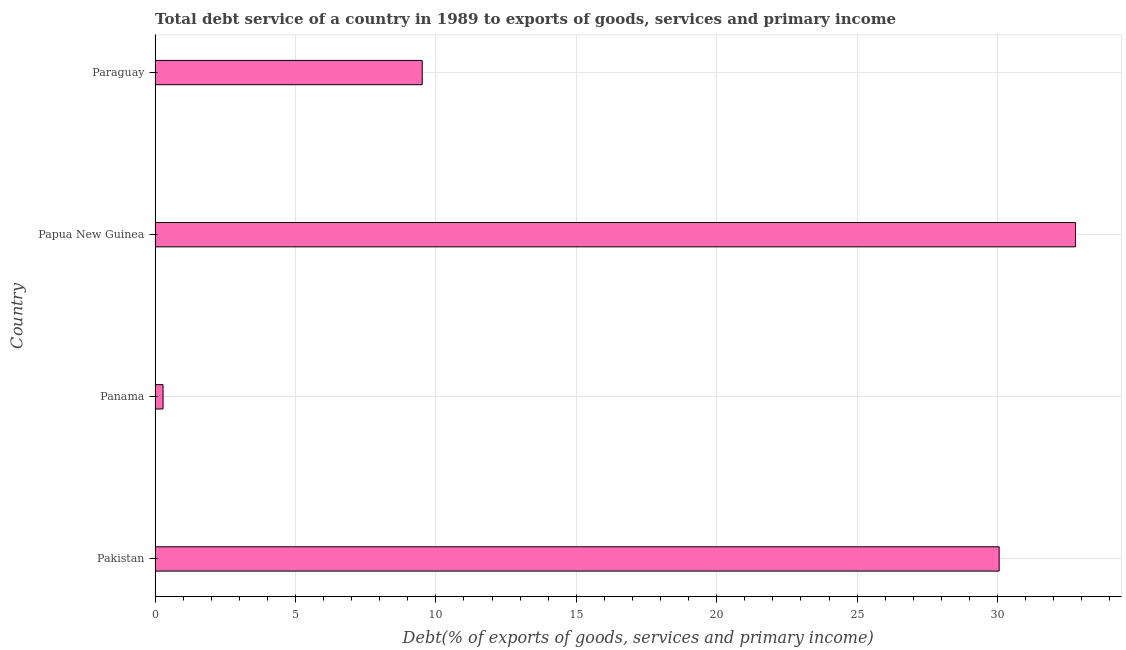Does the graph contain grids?
Make the answer very short. Yes. What is the title of the graph?
Offer a terse response. Total debt service of a country in 1989 to exports of goods, services and primary income. What is the label or title of the X-axis?
Offer a very short reply. Debt(% of exports of goods, services and primary income). What is the label or title of the Y-axis?
Your response must be concise. Country. What is the total debt service in Panama?
Provide a succinct answer. 0.28. Across all countries, what is the maximum total debt service?
Provide a short and direct response. 32.78. Across all countries, what is the minimum total debt service?
Your answer should be very brief. 0.28. In which country was the total debt service maximum?
Give a very brief answer. Papua New Guinea. In which country was the total debt service minimum?
Ensure brevity in your answer.  Panama. What is the sum of the total debt service?
Provide a succinct answer. 72.64. What is the difference between the total debt service in Papua New Guinea and Paraguay?
Your answer should be very brief. 23.26. What is the average total debt service per country?
Make the answer very short. 18.16. What is the median total debt service?
Provide a succinct answer. 19.79. In how many countries, is the total debt service greater than 26 %?
Ensure brevity in your answer.  2. What is the ratio of the total debt service in Pakistan to that in Papua New Guinea?
Make the answer very short. 0.92. Is the difference between the total debt service in Panama and Paraguay greater than the difference between any two countries?
Ensure brevity in your answer.  No. What is the difference between the highest and the second highest total debt service?
Ensure brevity in your answer.  2.72. What is the difference between the highest and the lowest total debt service?
Your response must be concise. 32.49. In how many countries, is the total debt service greater than the average total debt service taken over all countries?
Give a very brief answer. 2. How many countries are there in the graph?
Ensure brevity in your answer.  4. What is the difference between two consecutive major ticks on the X-axis?
Provide a short and direct response. 5. What is the Debt(% of exports of goods, services and primary income) of Pakistan?
Provide a succinct answer. 30.06. What is the Debt(% of exports of goods, services and primary income) in Panama?
Ensure brevity in your answer.  0.28. What is the Debt(% of exports of goods, services and primary income) in Papua New Guinea?
Your response must be concise. 32.78. What is the Debt(% of exports of goods, services and primary income) of Paraguay?
Ensure brevity in your answer.  9.51. What is the difference between the Debt(% of exports of goods, services and primary income) in Pakistan and Panama?
Your response must be concise. 29.78. What is the difference between the Debt(% of exports of goods, services and primary income) in Pakistan and Papua New Guinea?
Ensure brevity in your answer.  -2.72. What is the difference between the Debt(% of exports of goods, services and primary income) in Pakistan and Paraguay?
Offer a terse response. 20.55. What is the difference between the Debt(% of exports of goods, services and primary income) in Panama and Papua New Guinea?
Ensure brevity in your answer.  -32.49. What is the difference between the Debt(% of exports of goods, services and primary income) in Panama and Paraguay?
Provide a short and direct response. -9.23. What is the difference between the Debt(% of exports of goods, services and primary income) in Papua New Guinea and Paraguay?
Make the answer very short. 23.26. What is the ratio of the Debt(% of exports of goods, services and primary income) in Pakistan to that in Panama?
Your response must be concise. 105.69. What is the ratio of the Debt(% of exports of goods, services and primary income) in Pakistan to that in Papua New Guinea?
Provide a succinct answer. 0.92. What is the ratio of the Debt(% of exports of goods, services and primary income) in Pakistan to that in Paraguay?
Your answer should be very brief. 3.16. What is the ratio of the Debt(% of exports of goods, services and primary income) in Panama to that in Papua New Guinea?
Your answer should be compact. 0.01. What is the ratio of the Debt(% of exports of goods, services and primary income) in Panama to that in Paraguay?
Provide a short and direct response. 0.03. What is the ratio of the Debt(% of exports of goods, services and primary income) in Papua New Guinea to that in Paraguay?
Your answer should be compact. 3.44. 